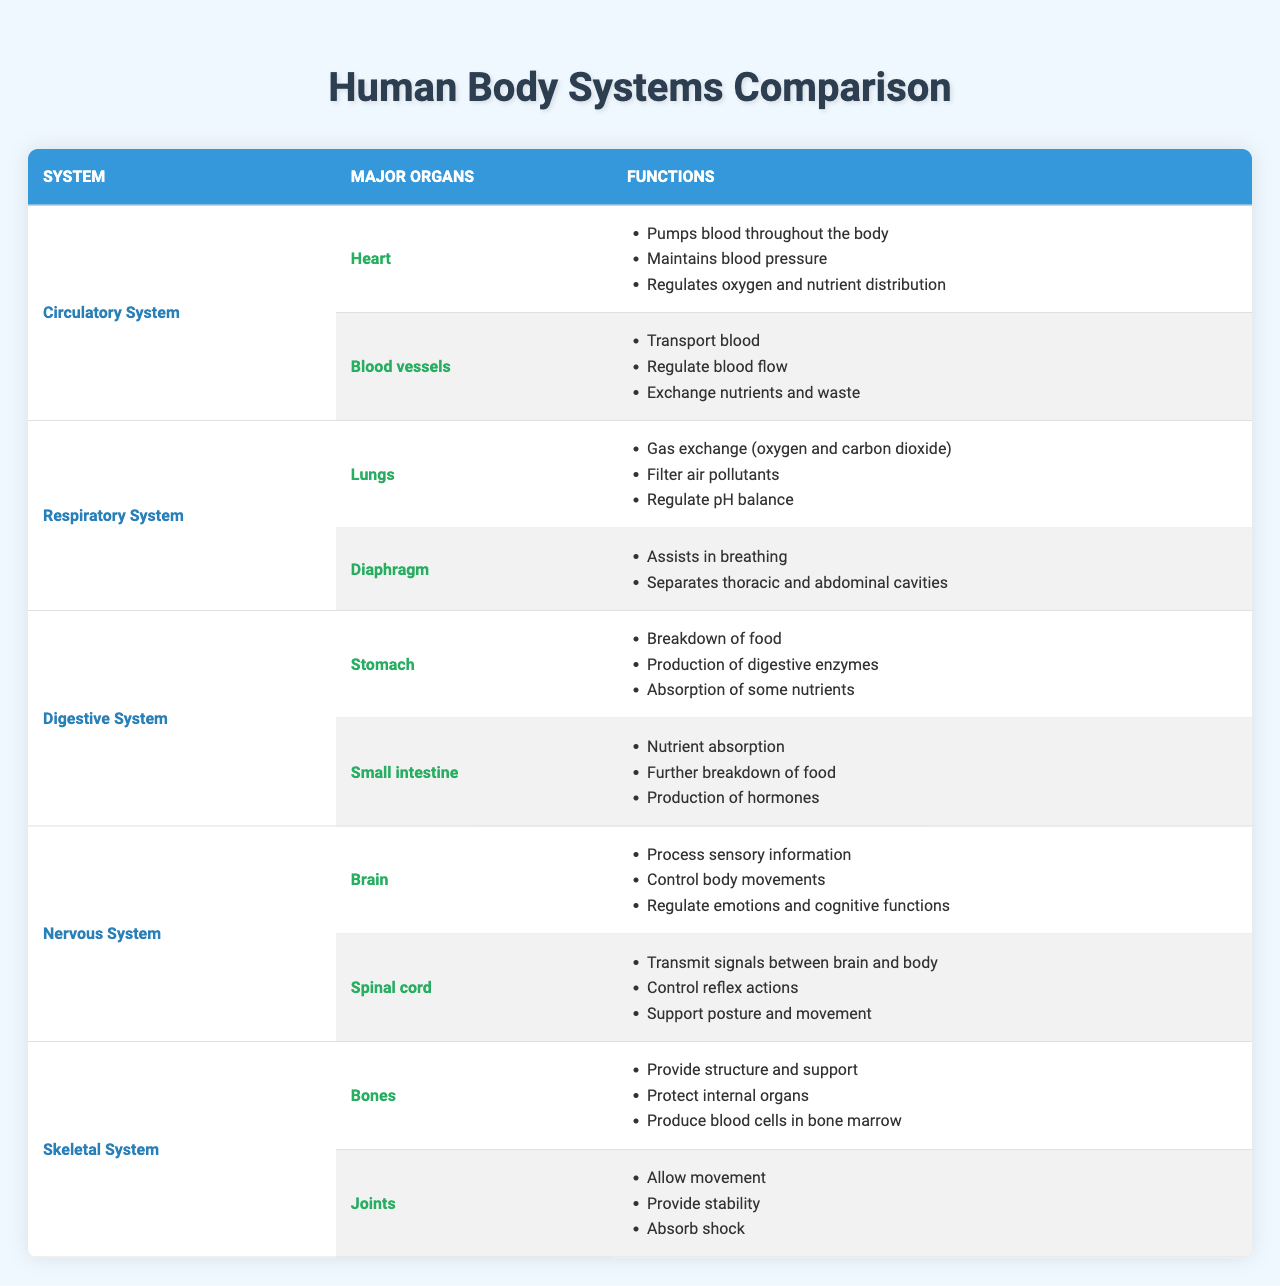What are the major organs of the Circulatory System? The table shows the major organs listed under the Circulatory System, which are the Heart and Blood vessels.
Answer: Heart, Blood vessels Which organ in the Respiratory System is responsible for gas exchange? According to the table, the Lungs are identified as the major organ responsible for gas exchange in the Respiratory System.
Answer: Lungs Do the Bones in the Skeletal System produce blood cells? The table indicates that one of the functions of Bones is to produce blood cells in the bone marrow, confirming the statement is true.
Answer: True What are the primary functions of the Stomach in the Digestive System? The table lists three functions of the Stomach: breakdown of food, production of digestive enzymes, and absorption of some nutrients.
Answer: Breakdown of food, production of digestive enzymes, absorption of some nutrients How many major organs are listed in the Nervous System? The Nervous System has two major organs listed: the Brain and Spinal cord, making the total count two.
Answer: 2 Which system does the diaphragm belong to? The table specifies that the diaphragm is a major organ in the Respiratory System.
Answer: Respiratory System What function is unique to the Lungs compared to other organs in the table? The Lungs have the unique function of gas exchange (oxygen and carbon dioxide) that is not listed for other organs in the table.
Answer: Gas exchange Which body system has the highest number of listed functions for its major organs? The Circulatory System has three functions for the Heart and three for Blood vessels, totaling six. The others either have fewer or the same number of total functions.
Answer: Circulatory System Can you identify an organ that assists in breathing? Based on the table, the diaphragm is identified as the organ that assists in breathing within the Respiratory System.
Answer: Diaphragm What is the main function of Joints in the Skeletal System? The main functions of Joints are to allow movement, provide stability, and absorb shock, as outlined in the table.
Answer: Allow movement, provide stability, absorb shock Which system's major organ is responsible for processing sensory information? The Brain, which is a major organ of the Nervous System, is responsible for processing sensory information.
Answer: Nervous System 